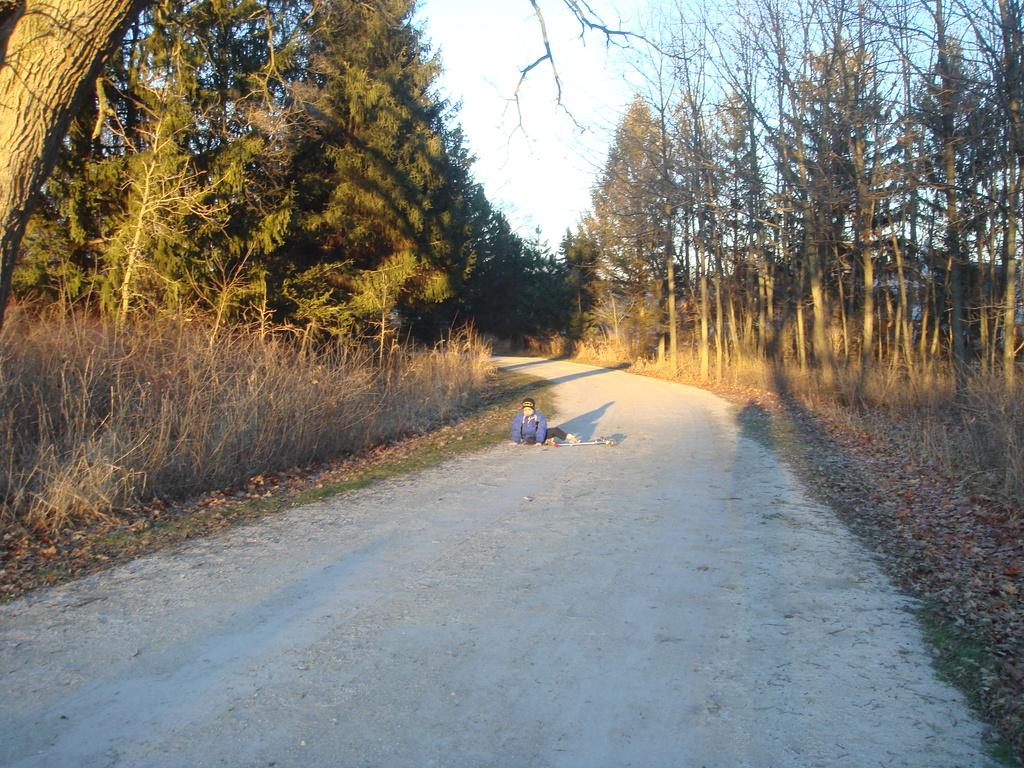What is the main subject of the image? There is a way in the image. What is the person sitting on in the image? The person is sitting on the way. What type of vegetation can be seen in the image? There is grass visible in the image. What else is present in the image besides the way and the person? There are trees in the image. What is visible at the top of the image? The sky is visible at the top of the image. Can you see any crayons lying on the grass in the image? There are no crayons present in the image. What type of bird can be seen flying over the trees in the image? There are no birds visible in the image. 